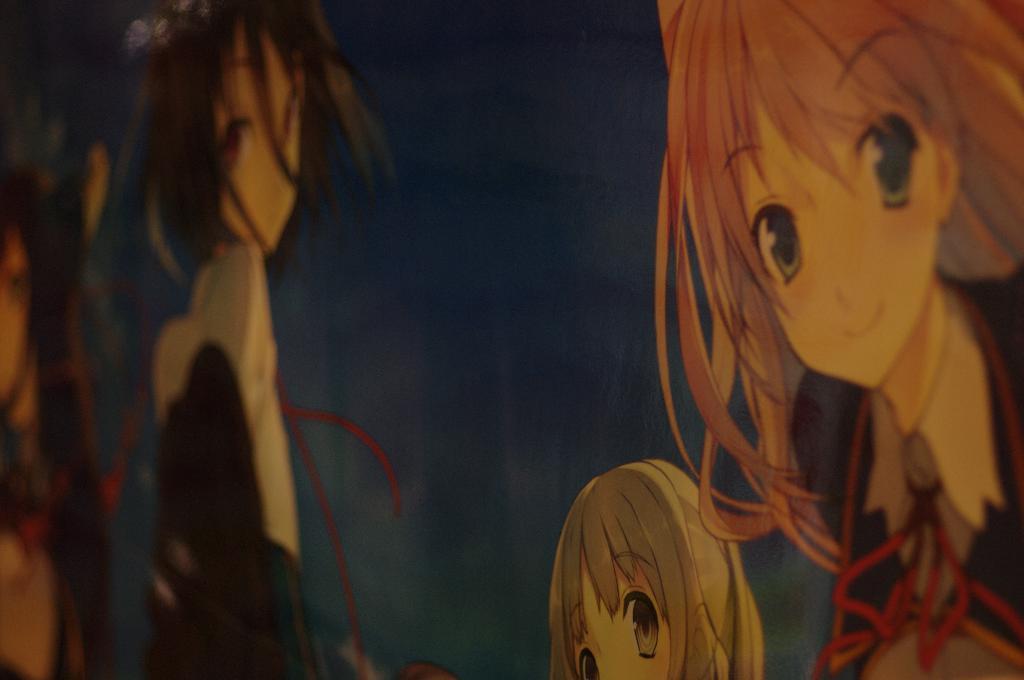Describe this image in one or two sentences. In this picture I can observe four cartoon images. Two of these cartoons are smiling. These are the images of girls. The background is dark. 